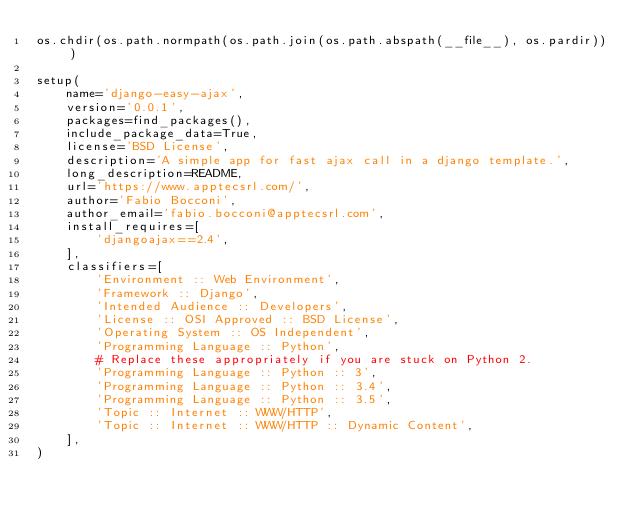<code> <loc_0><loc_0><loc_500><loc_500><_Python_>os.chdir(os.path.normpath(os.path.join(os.path.abspath(__file__), os.pardir)))

setup(
    name='django-easy-ajax',
    version='0.0.1',
    packages=find_packages(),
    include_package_data=True,
    license='BSD License',
    description='A simple app for fast ajax call in a django template.',
    long_description=README,
    url='https://www.apptecsrl.com/',
    author='Fabio Bocconi',
    author_email='fabio.bocconi@apptecsrl.com',
    install_requires=[
        'djangoajax==2.4',
    ],
    classifiers=[
        'Environment :: Web Environment',
        'Framework :: Django',
        'Intended Audience :: Developers',
        'License :: OSI Approved :: BSD License',
        'Operating System :: OS Independent',
        'Programming Language :: Python',
        # Replace these appropriately if you are stuck on Python 2.
        'Programming Language :: Python :: 3',
        'Programming Language :: Python :: 3.4',
        'Programming Language :: Python :: 3.5',
        'Topic :: Internet :: WWW/HTTP',
        'Topic :: Internet :: WWW/HTTP :: Dynamic Content',
    ],
)
</code> 